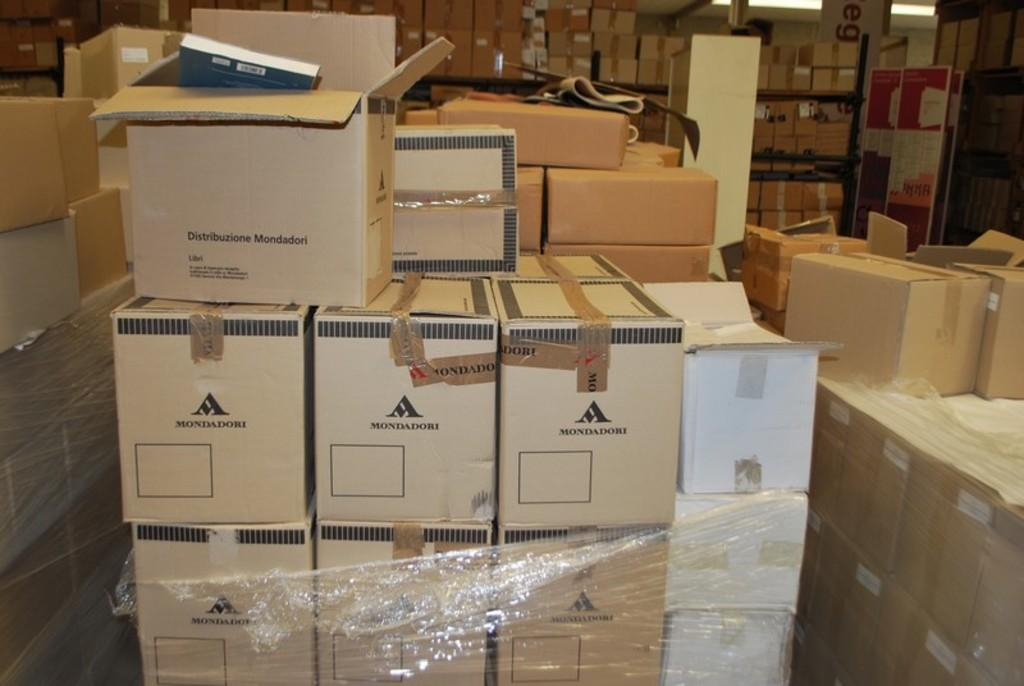Provide a one-sentence caption for the provided image. Boxes with a Mondadori logo are stacked on top of each other. 